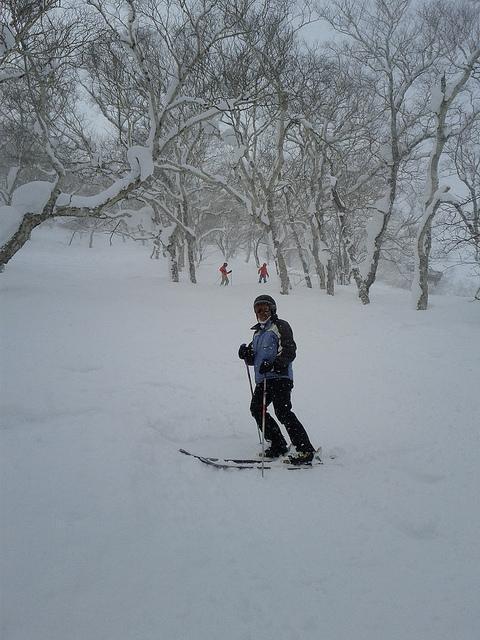How many skiers are in the distance?
Give a very brief answer. 2. 